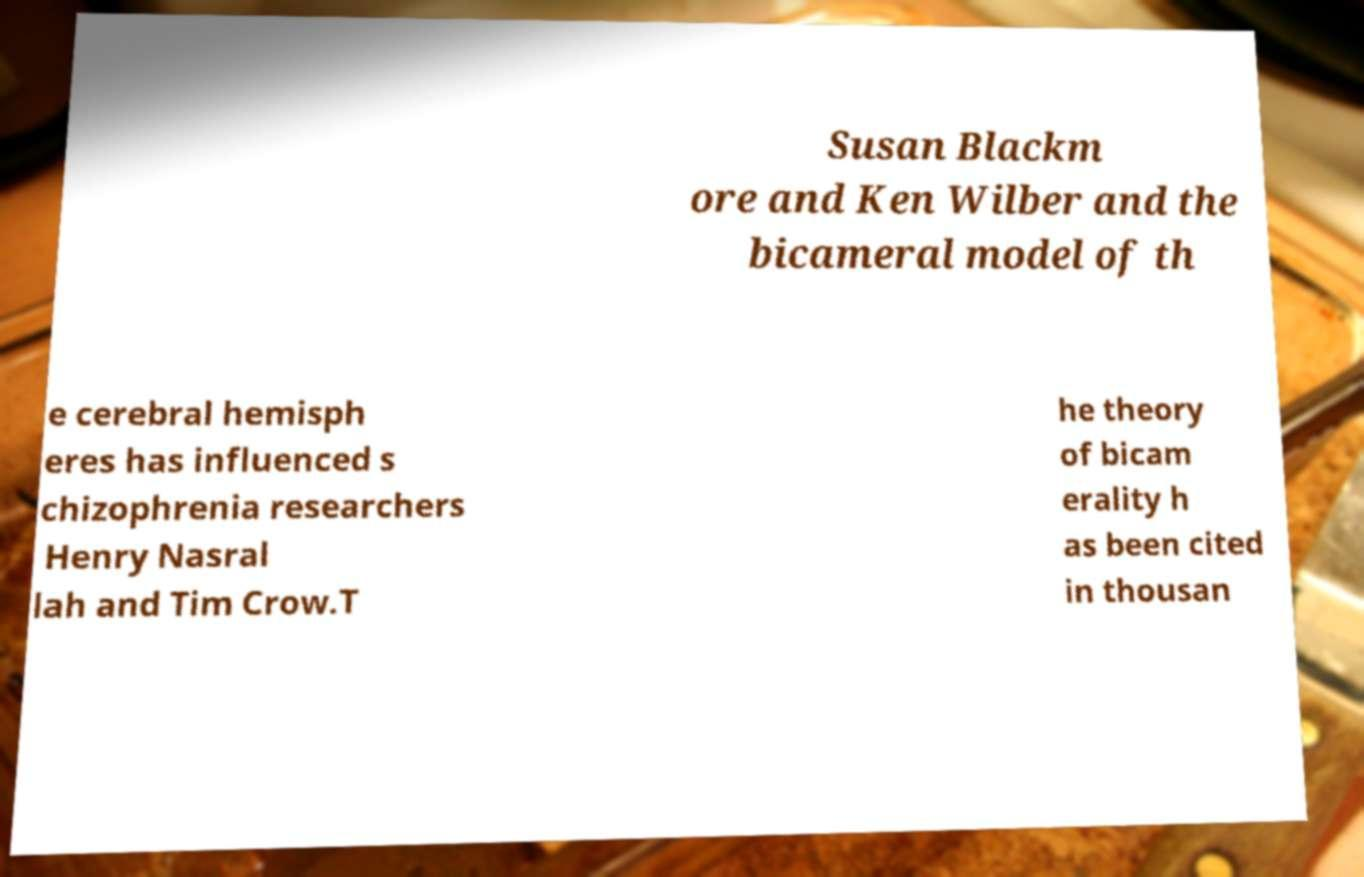Can you read and provide the text displayed in the image?This photo seems to have some interesting text. Can you extract and type it out for me? Susan Blackm ore and Ken Wilber and the bicameral model of th e cerebral hemisph eres has influenced s chizophrenia researchers Henry Nasral lah and Tim Crow.T he theory of bicam erality h as been cited in thousan 